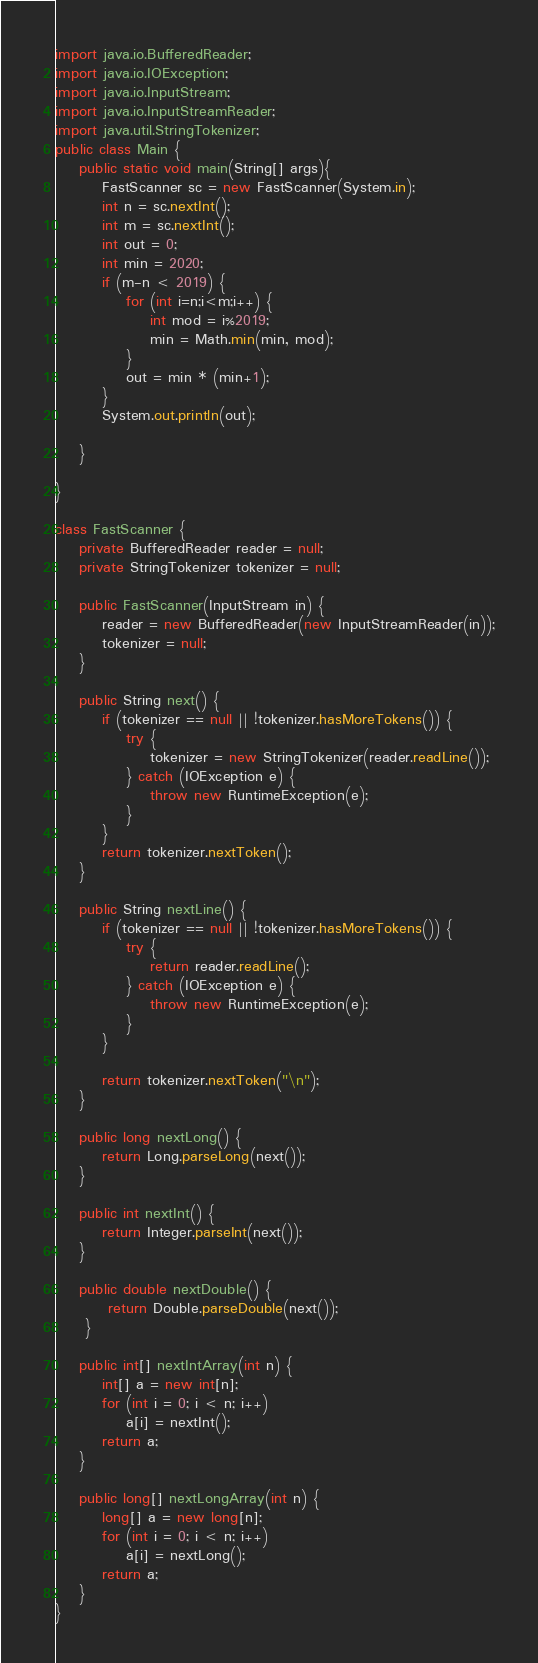<code> <loc_0><loc_0><loc_500><loc_500><_Java_>import java.io.BufferedReader;
import java.io.IOException;
import java.io.InputStream;
import java.io.InputStreamReader;
import java.util.StringTokenizer;
public class Main {
	public static void main(String[] args){
		FastScanner sc = new FastScanner(System.in);
		int n = sc.nextInt();
		int m = sc.nextInt();
		int out = 0;
		int min = 2020;
		if (m-n < 2019) {
			for (int i=n;i<m;i++) {
				int mod = i%2019;
				min = Math.min(min, mod);
			}
			out = min * (min+1);
		}
		System.out.println(out);

	}

}

class FastScanner {
    private BufferedReader reader = null;
    private StringTokenizer tokenizer = null;

    public FastScanner(InputStream in) {
        reader = new BufferedReader(new InputStreamReader(in));
        tokenizer = null;
    }

    public String next() {
        if (tokenizer == null || !tokenizer.hasMoreTokens()) {
            try {
                tokenizer = new StringTokenizer(reader.readLine());
            } catch (IOException e) {
                throw new RuntimeException(e);
            }
        }
        return tokenizer.nextToken();
    }

    public String nextLine() {
        if (tokenizer == null || !tokenizer.hasMoreTokens()) {
            try {
                return reader.readLine();
            } catch (IOException e) {
                throw new RuntimeException(e);
            }
        }

        return tokenizer.nextToken("\n");
    }

    public long nextLong() {
        return Long.parseLong(next());
    }

    public int nextInt() {
        return Integer.parseInt(next());
    }

    public double nextDouble() {
         return Double.parseDouble(next());
     }

    public int[] nextIntArray(int n) {
        int[] a = new int[n];
        for (int i = 0; i < n; i++)
            a[i] = nextInt();
        return a;
    }

    public long[] nextLongArray(int n) {
        long[] a = new long[n];
        for (int i = 0; i < n; i++)
            a[i] = nextLong();
        return a;
    }
}</code> 